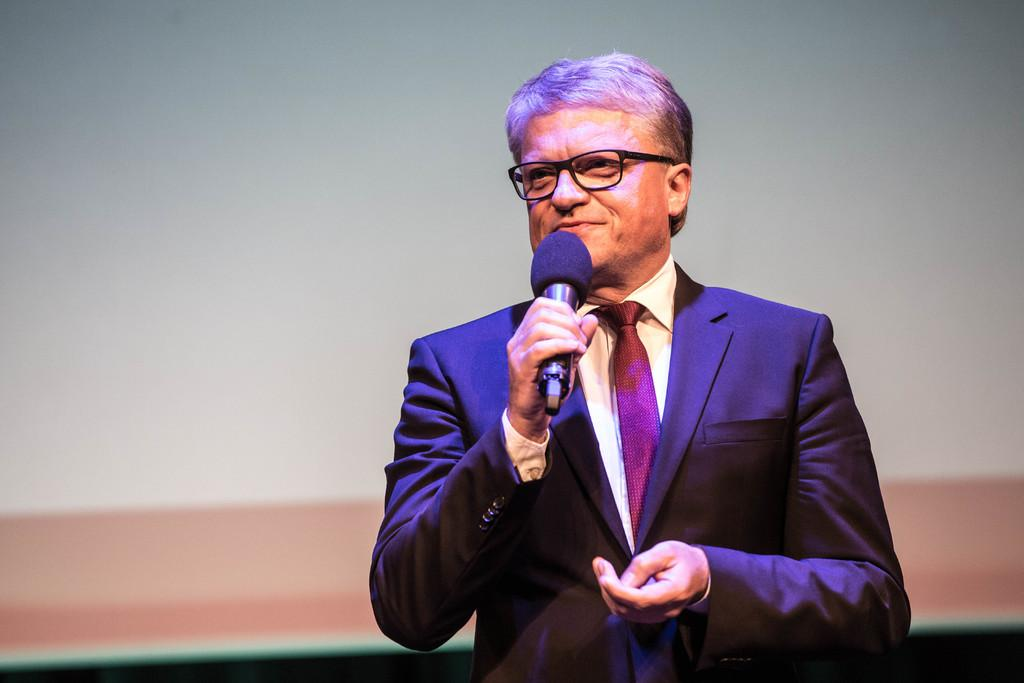Who is the main subject in the image? There is a man in the image. What is the man doing in the image? The man is speaking in the image. What object is the man holding in the image? The man is holding a microphone in the image. Can you describe any accessories the man is wearing in the image? Yes, the man is wearing spectacles in the image. What can be seen in the background of the image? There is a wall visible in the background of the image. How many tickets can be seen in the image? There are no tickets present in the image. 